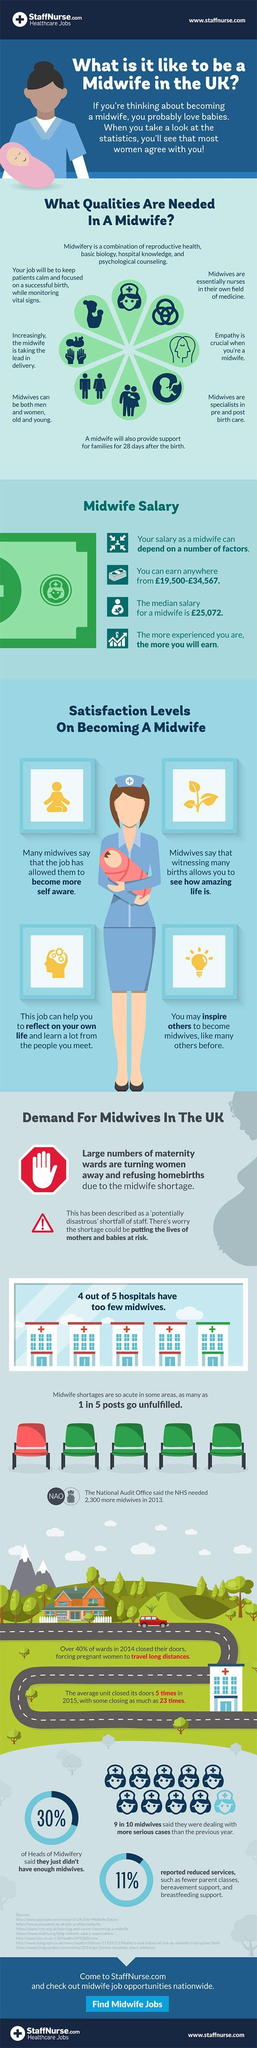If taken a sample of 10 midwifes, how many believe they are handling more complicated cases than last year?
Answer the question with a short phrase. 9 in 10 midwives 